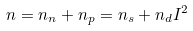Convert formula to latex. <formula><loc_0><loc_0><loc_500><loc_500>n = n _ { n } + n _ { p } = n _ { s } + n _ { d } I ^ { 2 }</formula> 